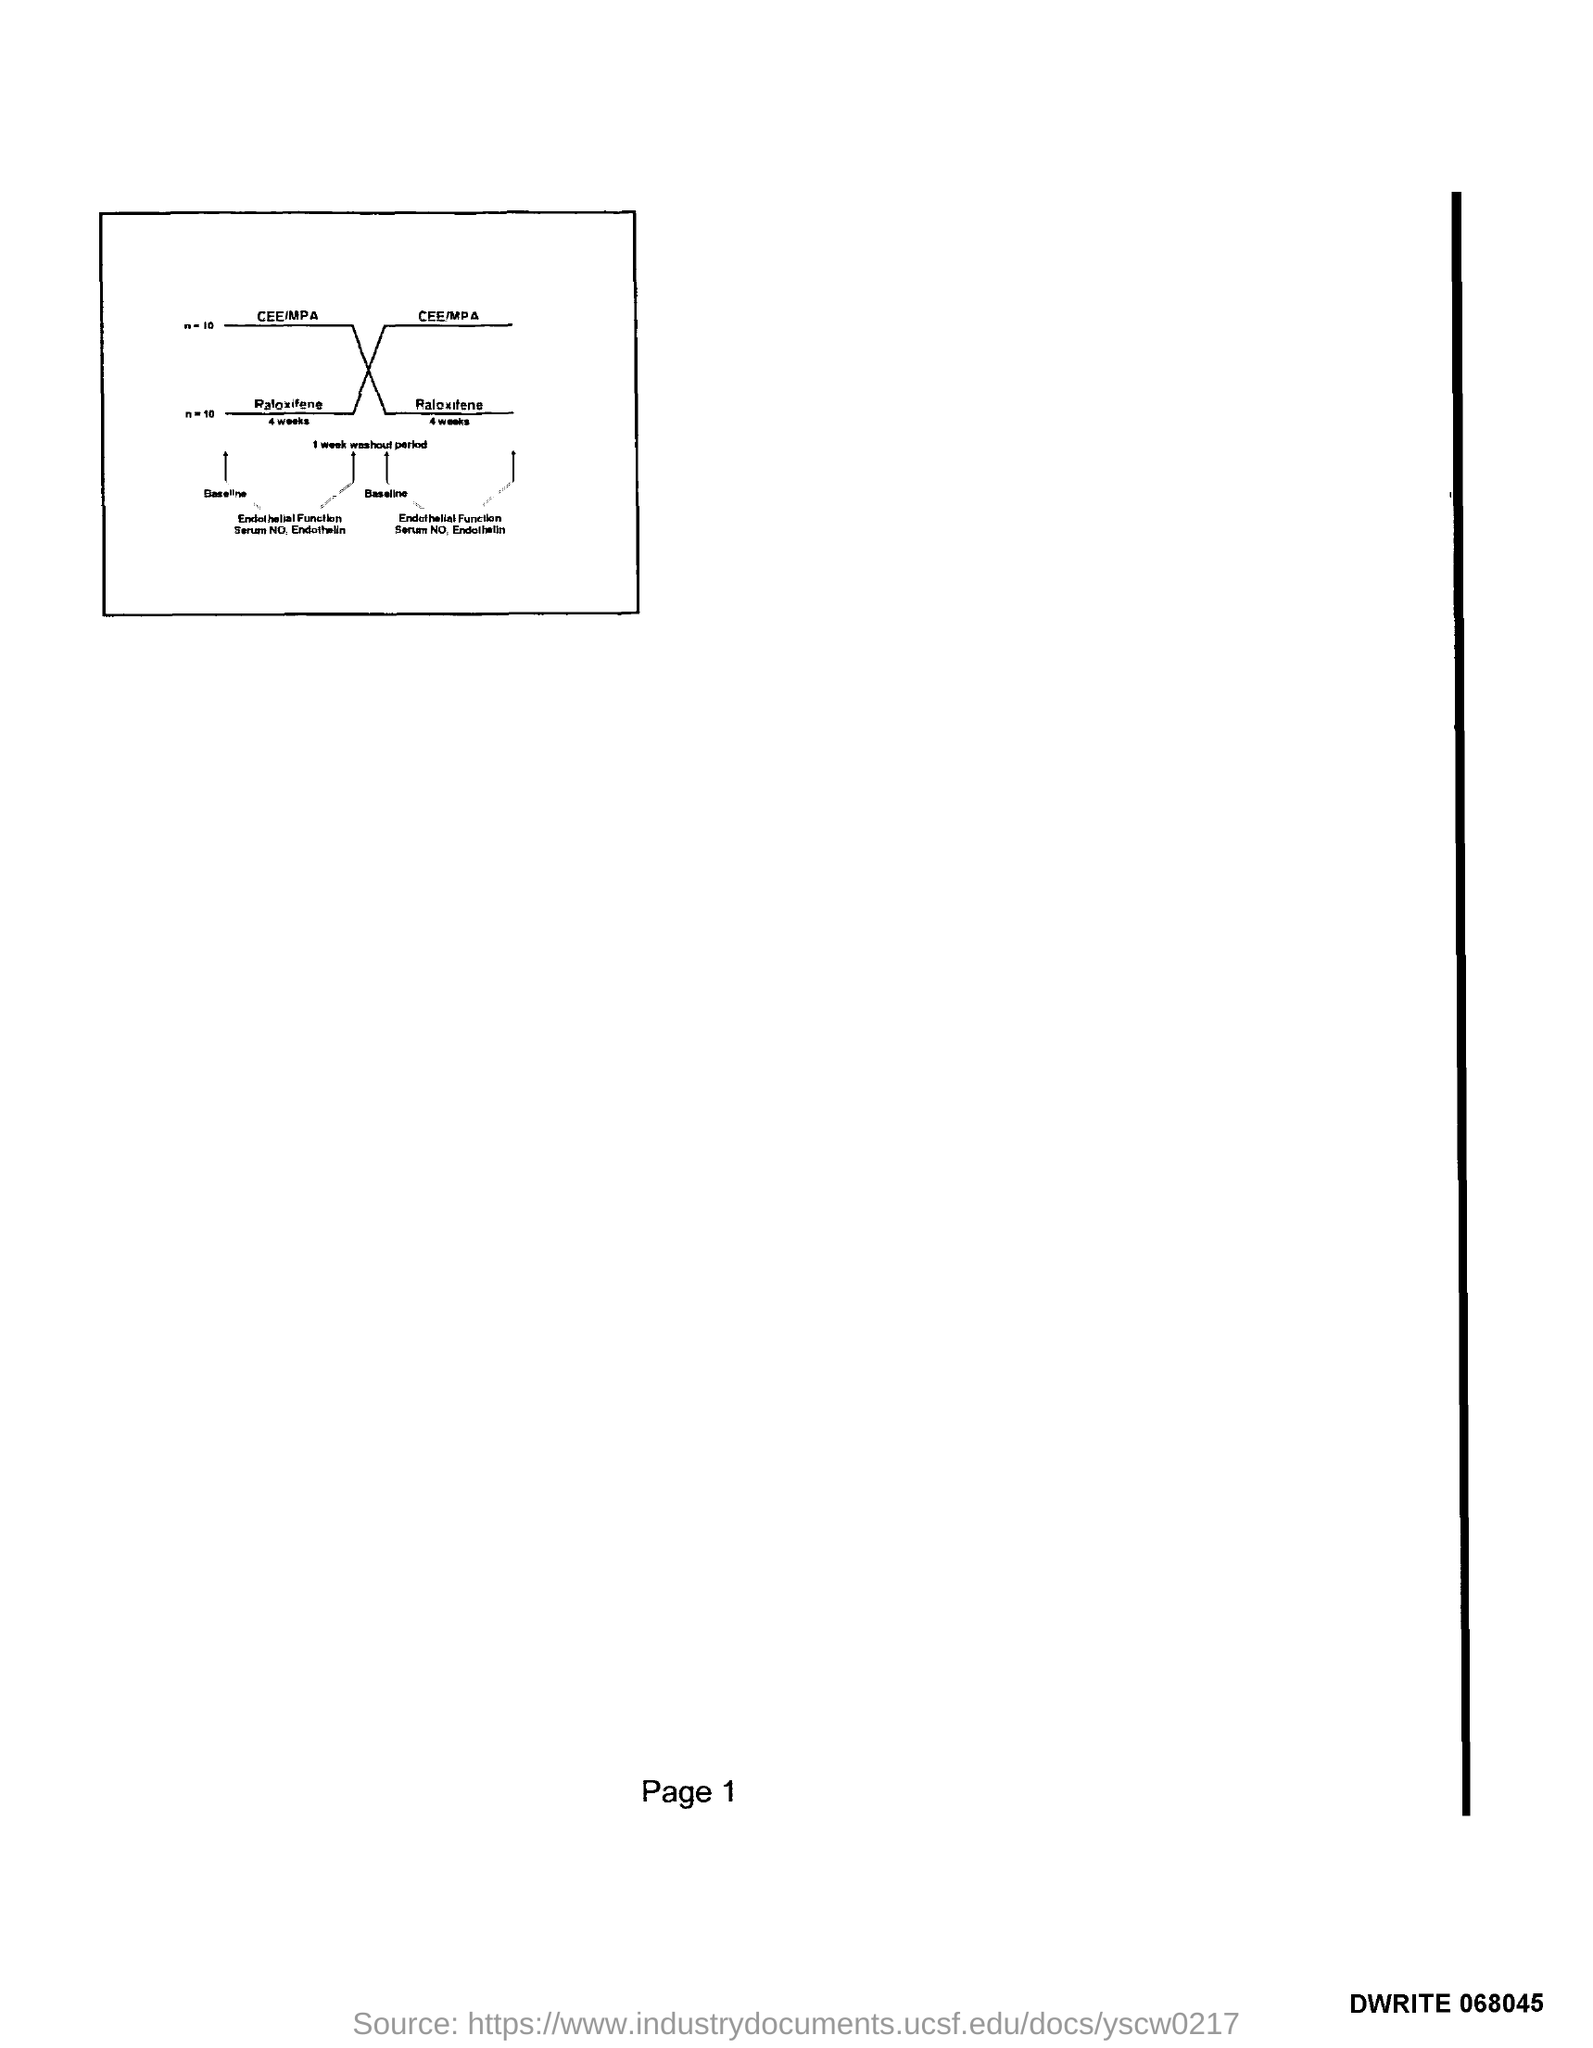What is the Page Number?
Your response must be concise. 1. 